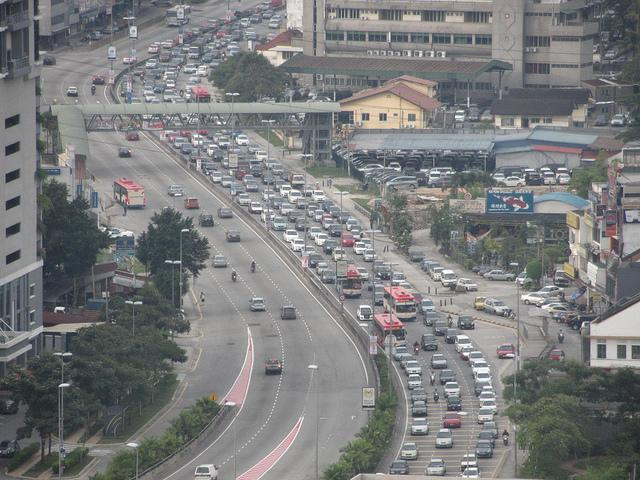What time is it likely to be?

Choices:
A) noon
B) 845 am
C) midnight
D) dusk 845 am 